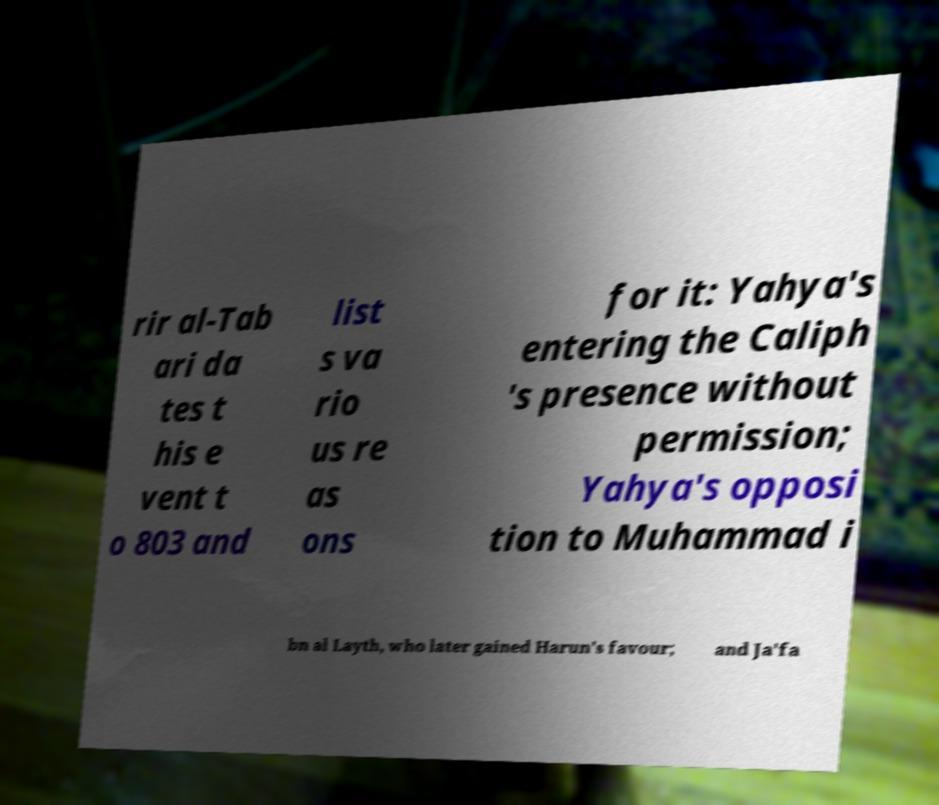Could you assist in decoding the text presented in this image and type it out clearly? rir al-Tab ari da tes t his e vent t o 803 and list s va rio us re as ons for it: Yahya's entering the Caliph 's presence without permission; Yahya's opposi tion to Muhammad i bn al Layth, who later gained Harun's favour; and Ja'fa 